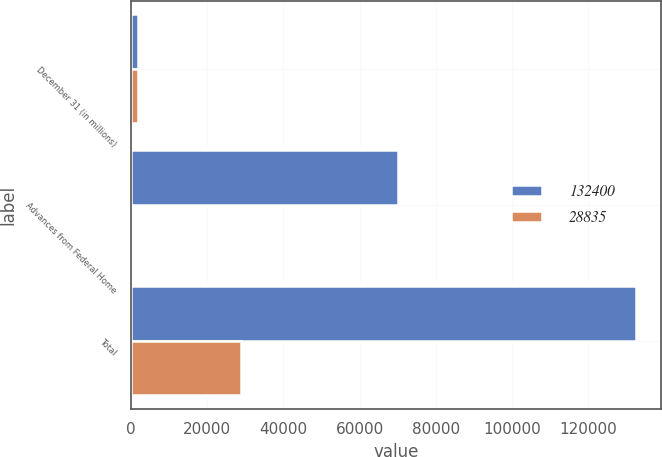Convert chart. <chart><loc_0><loc_0><loc_500><loc_500><stacked_bar_chart><ecel><fcel>December 31 (in millions)<fcel>Advances from Federal Home<fcel>Total<nl><fcel>132400<fcel>2008<fcel>70187<fcel>132400<nl><fcel>28835<fcel>2007<fcel>450<fcel>28835<nl></chart> 